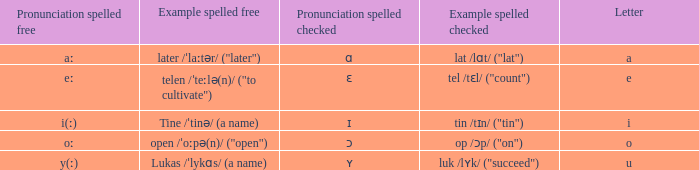What is Pronunciation Spelled Free, when Pronunciation Spelled Checked is "ɛ"? Eː. 